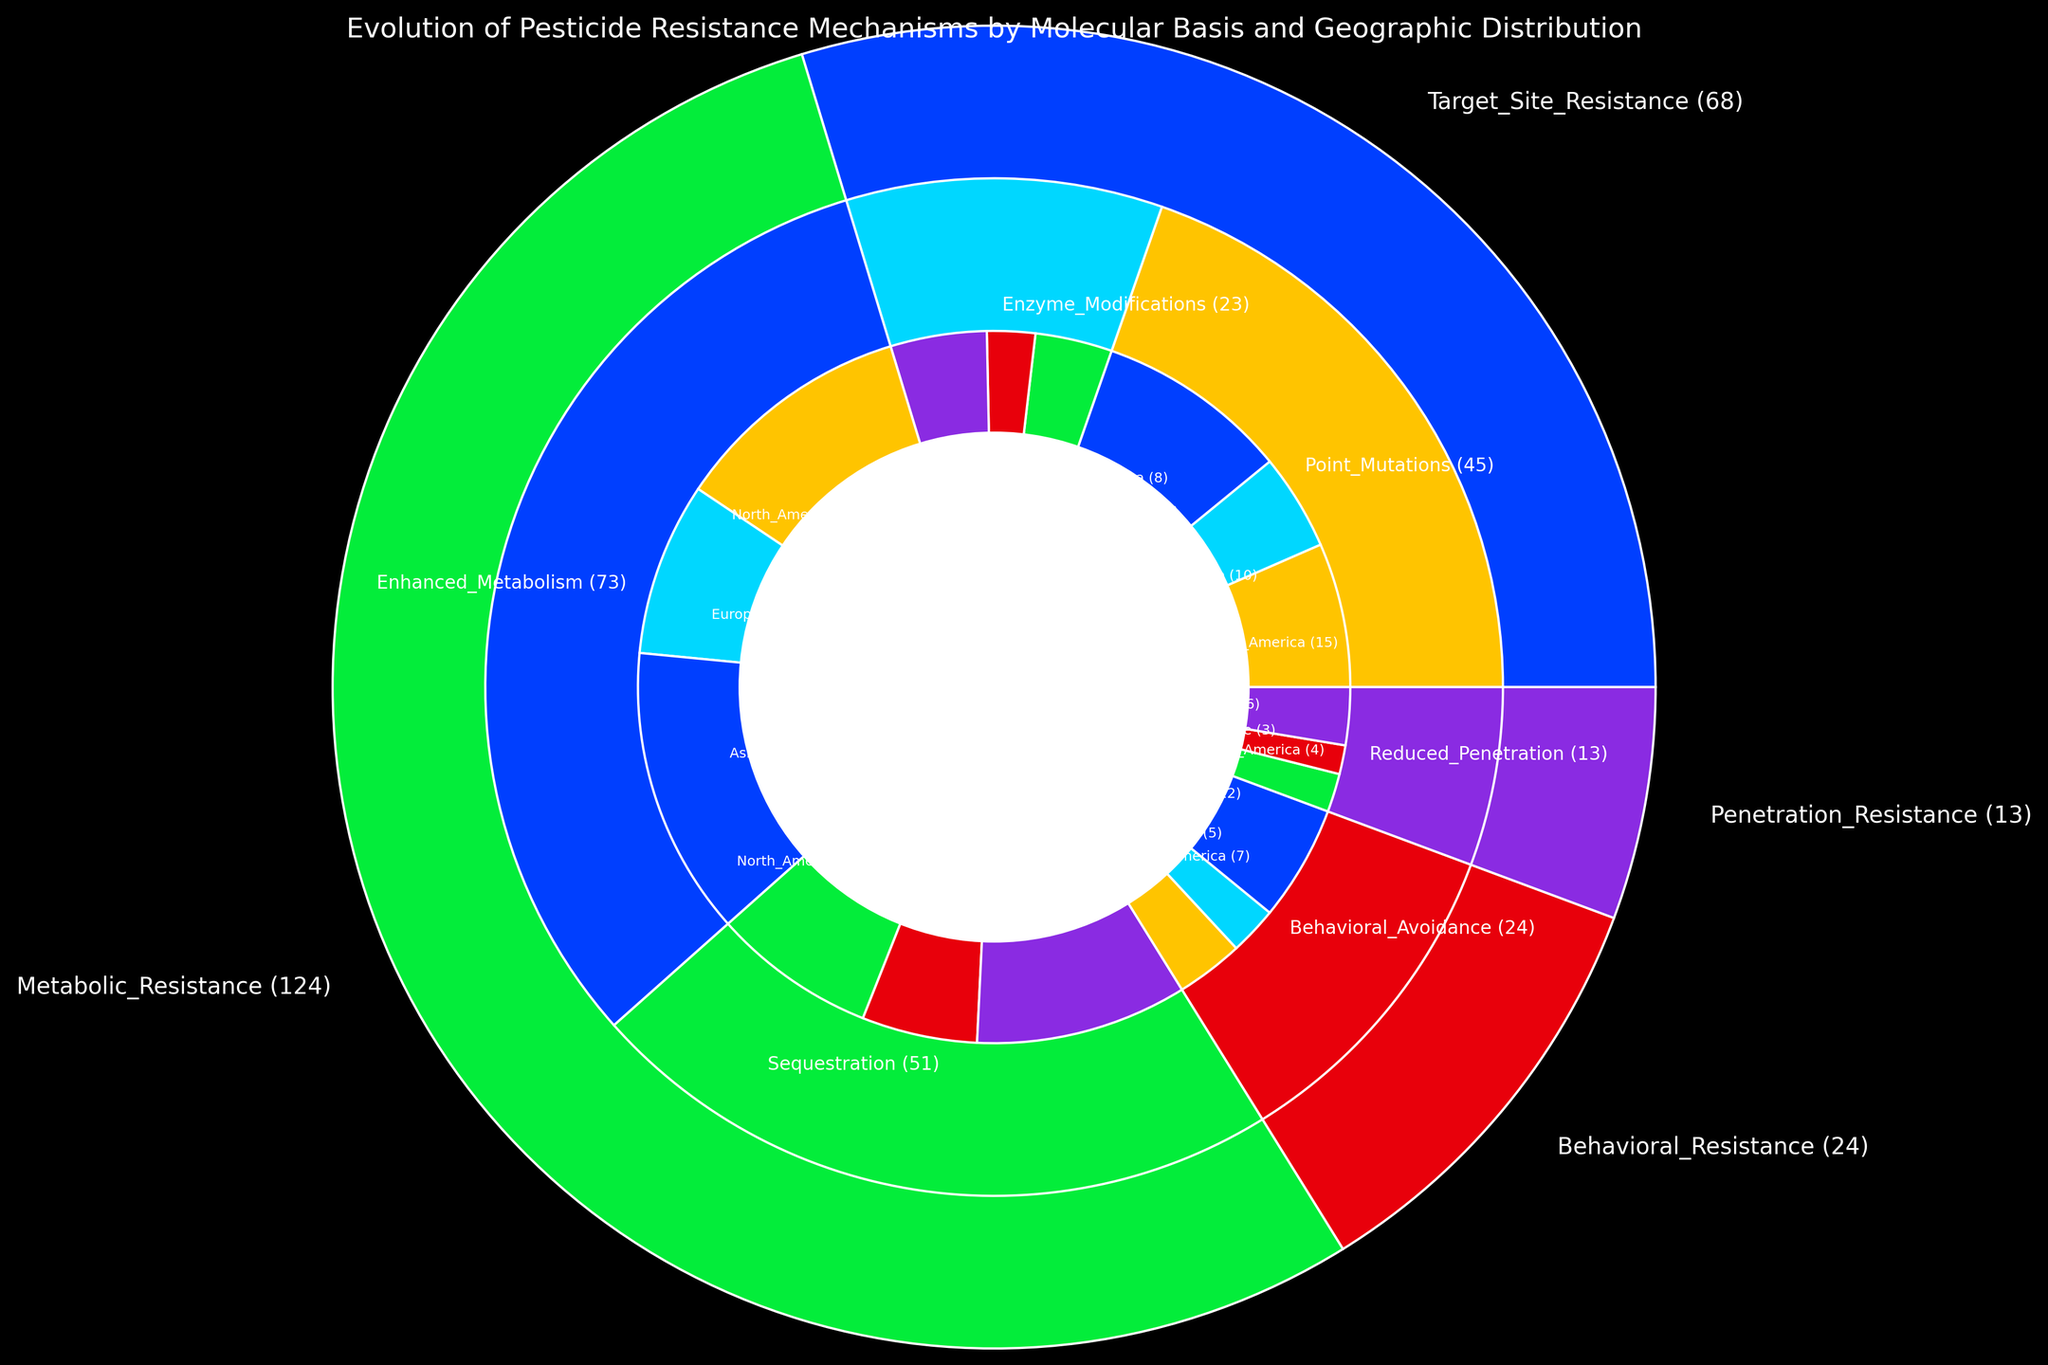Which region has the highest count of Target Site Resistance due to Point Mutations? To find the answer, look at the regional counts for Target Site Resistance due to Point Mutations in the figure. Compare the counts for North America, Europe, and Asia. Asia has the highest count here.
Answer: Asia What is the total count of Metabolic Resistance mechanisms across all regions? Sum the counts of all sub-categories under Metabolic Resistance from the regions. Enhanced Metabolism (25 + 18 + 30) + Sequestration (17 + 12 + 22). So, 73 (Enhanced Metabolism) + 51 (Sequestration) = 124.
Answer: 124 Which mechanism has the least representation in Europe? Compare all sub-categories in Europe. Reduced Penetration (3) has the lowest count compared to others: Point Mutations (10), Enzyme Modifications (5), Enhanced Metabolism (18), Sequestration (12), Behavioral Avoidance (5).
Answer: Reduced Penetration What is the difference in the count of Enhanced Metabolism between Asia and North America? Subtract the count of Enhanced Metabolism in North America from that in Asia. So, 30 (Asia) - 25 (North America) = 5.
Answer: 5 Which region exhibits the highest total count of Behavioral Resistance? Sum the counts of Behavioral Avoidance in each region. North America (7) + Europe (5) + Asia (12). Asia has the highest count.
Answer: Asia How does the count of Sequestration in Europe compare to the count of Enzyme Modifications in Europe? Look at counts for Sequestration and Enzyme Modifications in Europe. Compare 12 (Sequestration) to 5 (Enzyme Modifications). Sequestration is higher.
Answer: Sequestration is higher Which resistance mechanism has the highest overall count, and what is that count? Sum the counts for each resistance mechanism and compare. Metabolic Resistance has the highest count: 124 (Enhanced Metabolism) + 51 (Sequestration) = 175.
Answer: Metabolic Resistance, 175 Is the count of Point Mutations in Europe higher or lower than the count of Enzyme Modifications in Asia? Point Mutations in Europe is 10, whereas Enzyme Modifications in Asia is 10. Both are equal.
Answer: Equal What is the average count of Enhanced Metabolism across all regions? Sum the counts of Enhanced Metabolism across regions and divide by the number of regions. (25 + 18 + 30) / 3 = 24.33.
Answer: 24.33 